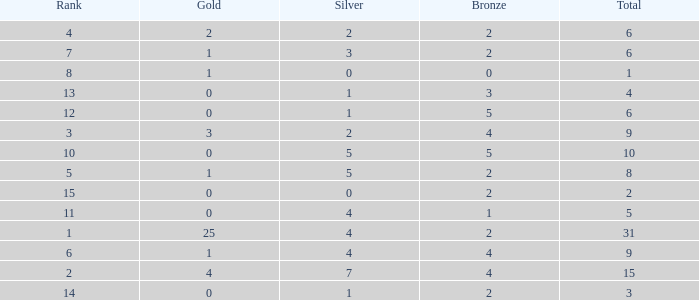What is the highest rank of the medal total less than 15, more than 2 bronzes, 0 gold and 1 silver? 13.0. 